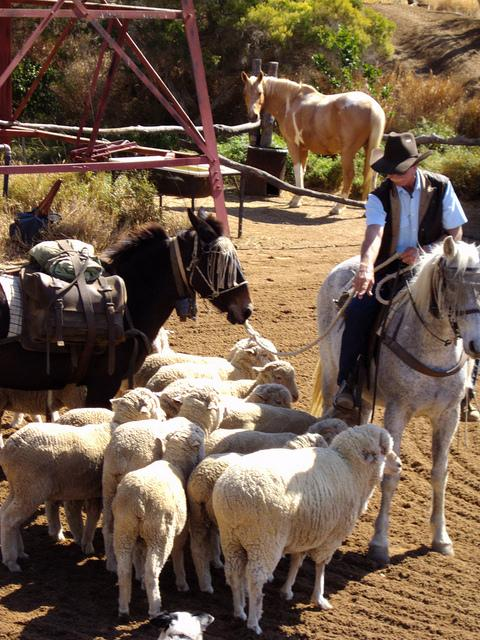What other animal could help here? Please explain your reasoning. dogs. The sheep dogs could help 